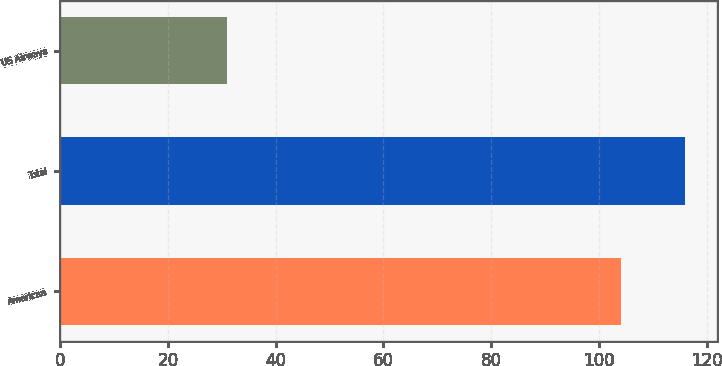<chart> <loc_0><loc_0><loc_500><loc_500><bar_chart><fcel>American<fcel>Total<fcel>US Airways<nl><fcel>104<fcel>116<fcel>31<nl></chart> 